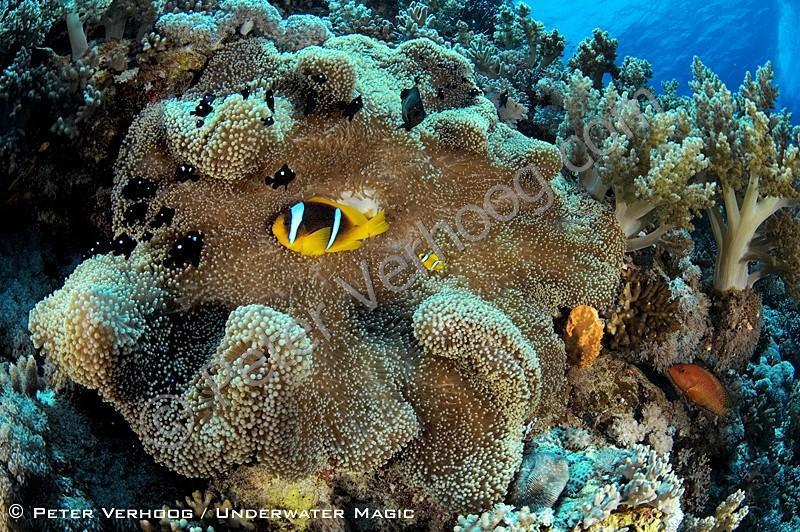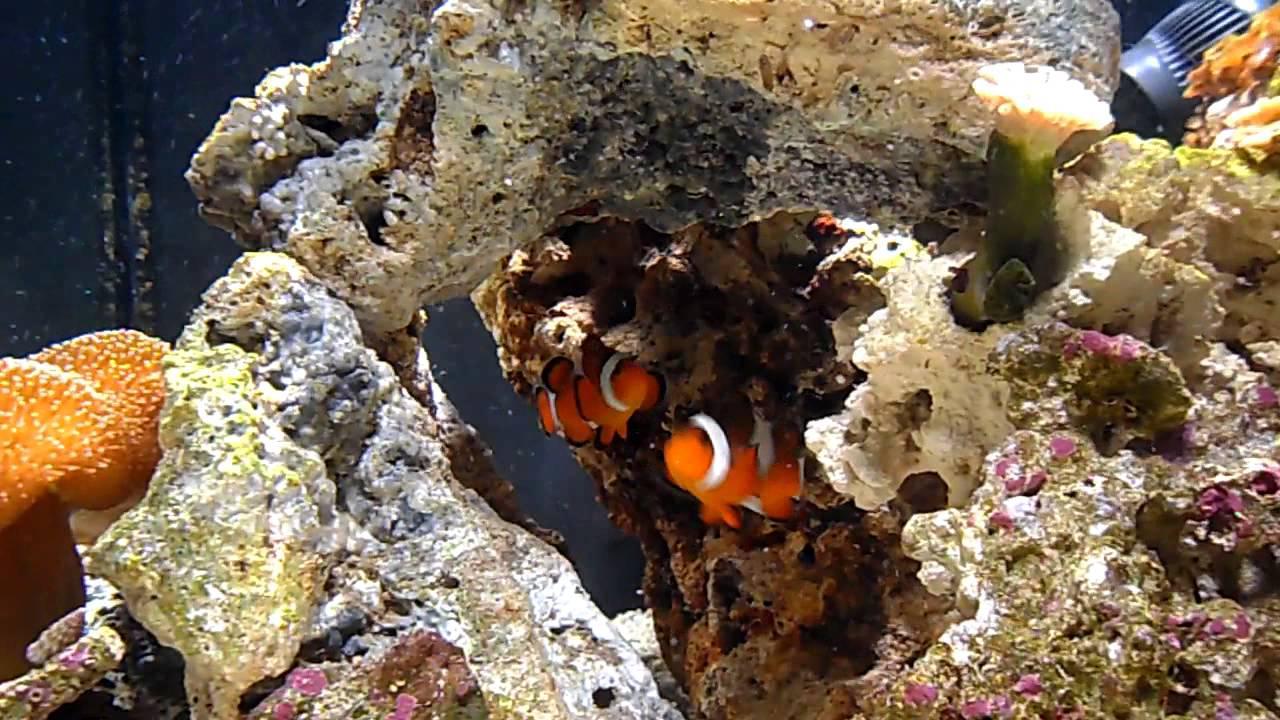The first image is the image on the left, the second image is the image on the right. Examine the images to the left and right. Is the description "One image includes two close together fish that are bright orange with white stripe, and the other image includes a yellower fish with white stripes." accurate? Answer yes or no. Yes. The first image is the image on the left, the second image is the image on the right. Analyze the images presented: Is the assertion "There are two orange fish in one of the images." valid? Answer yes or no. Yes. 